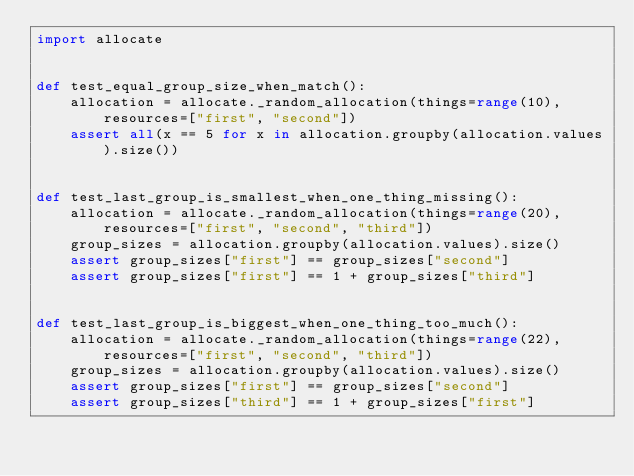Convert code to text. <code><loc_0><loc_0><loc_500><loc_500><_Python_>import allocate


def test_equal_group_size_when_match():
    allocation = allocate._random_allocation(things=range(10), resources=["first", "second"])
    assert all(x == 5 for x in allocation.groupby(allocation.values).size())


def test_last_group_is_smallest_when_one_thing_missing():
    allocation = allocate._random_allocation(things=range(20), resources=["first", "second", "third"])
    group_sizes = allocation.groupby(allocation.values).size()
    assert group_sizes["first"] == group_sizes["second"]
    assert group_sizes["first"] == 1 + group_sizes["third"]


def test_last_group_is_biggest_when_one_thing_too_much():
    allocation = allocate._random_allocation(things=range(22), resources=["first", "second", "third"])
    group_sizes = allocation.groupby(allocation.values).size()
    assert group_sizes["first"] == group_sizes["second"]
    assert group_sizes["third"] == 1 + group_sizes["first"]
</code> 